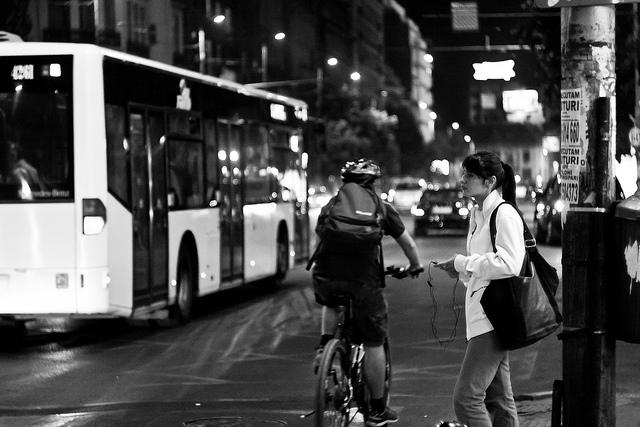What should the bus use to safely move in front of the bicyclist? turn signal 